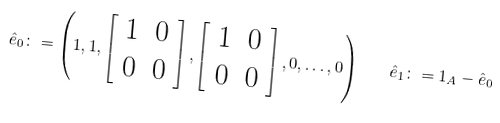<formula> <loc_0><loc_0><loc_500><loc_500>\hat { e } _ { 0 } \colon = \left ( 1 , 1 , \left [ \begin{array} { c c } 1 & 0 \\ 0 & 0 \end{array} \right ] , \left [ \begin{array} { c c } 1 & 0 \\ 0 & 0 \end{array} \right ] , 0 , \dots , 0 \right ) \quad \hat { e } _ { 1 } \colon = 1 _ { A } - \hat { e } _ { 0 }</formula> 